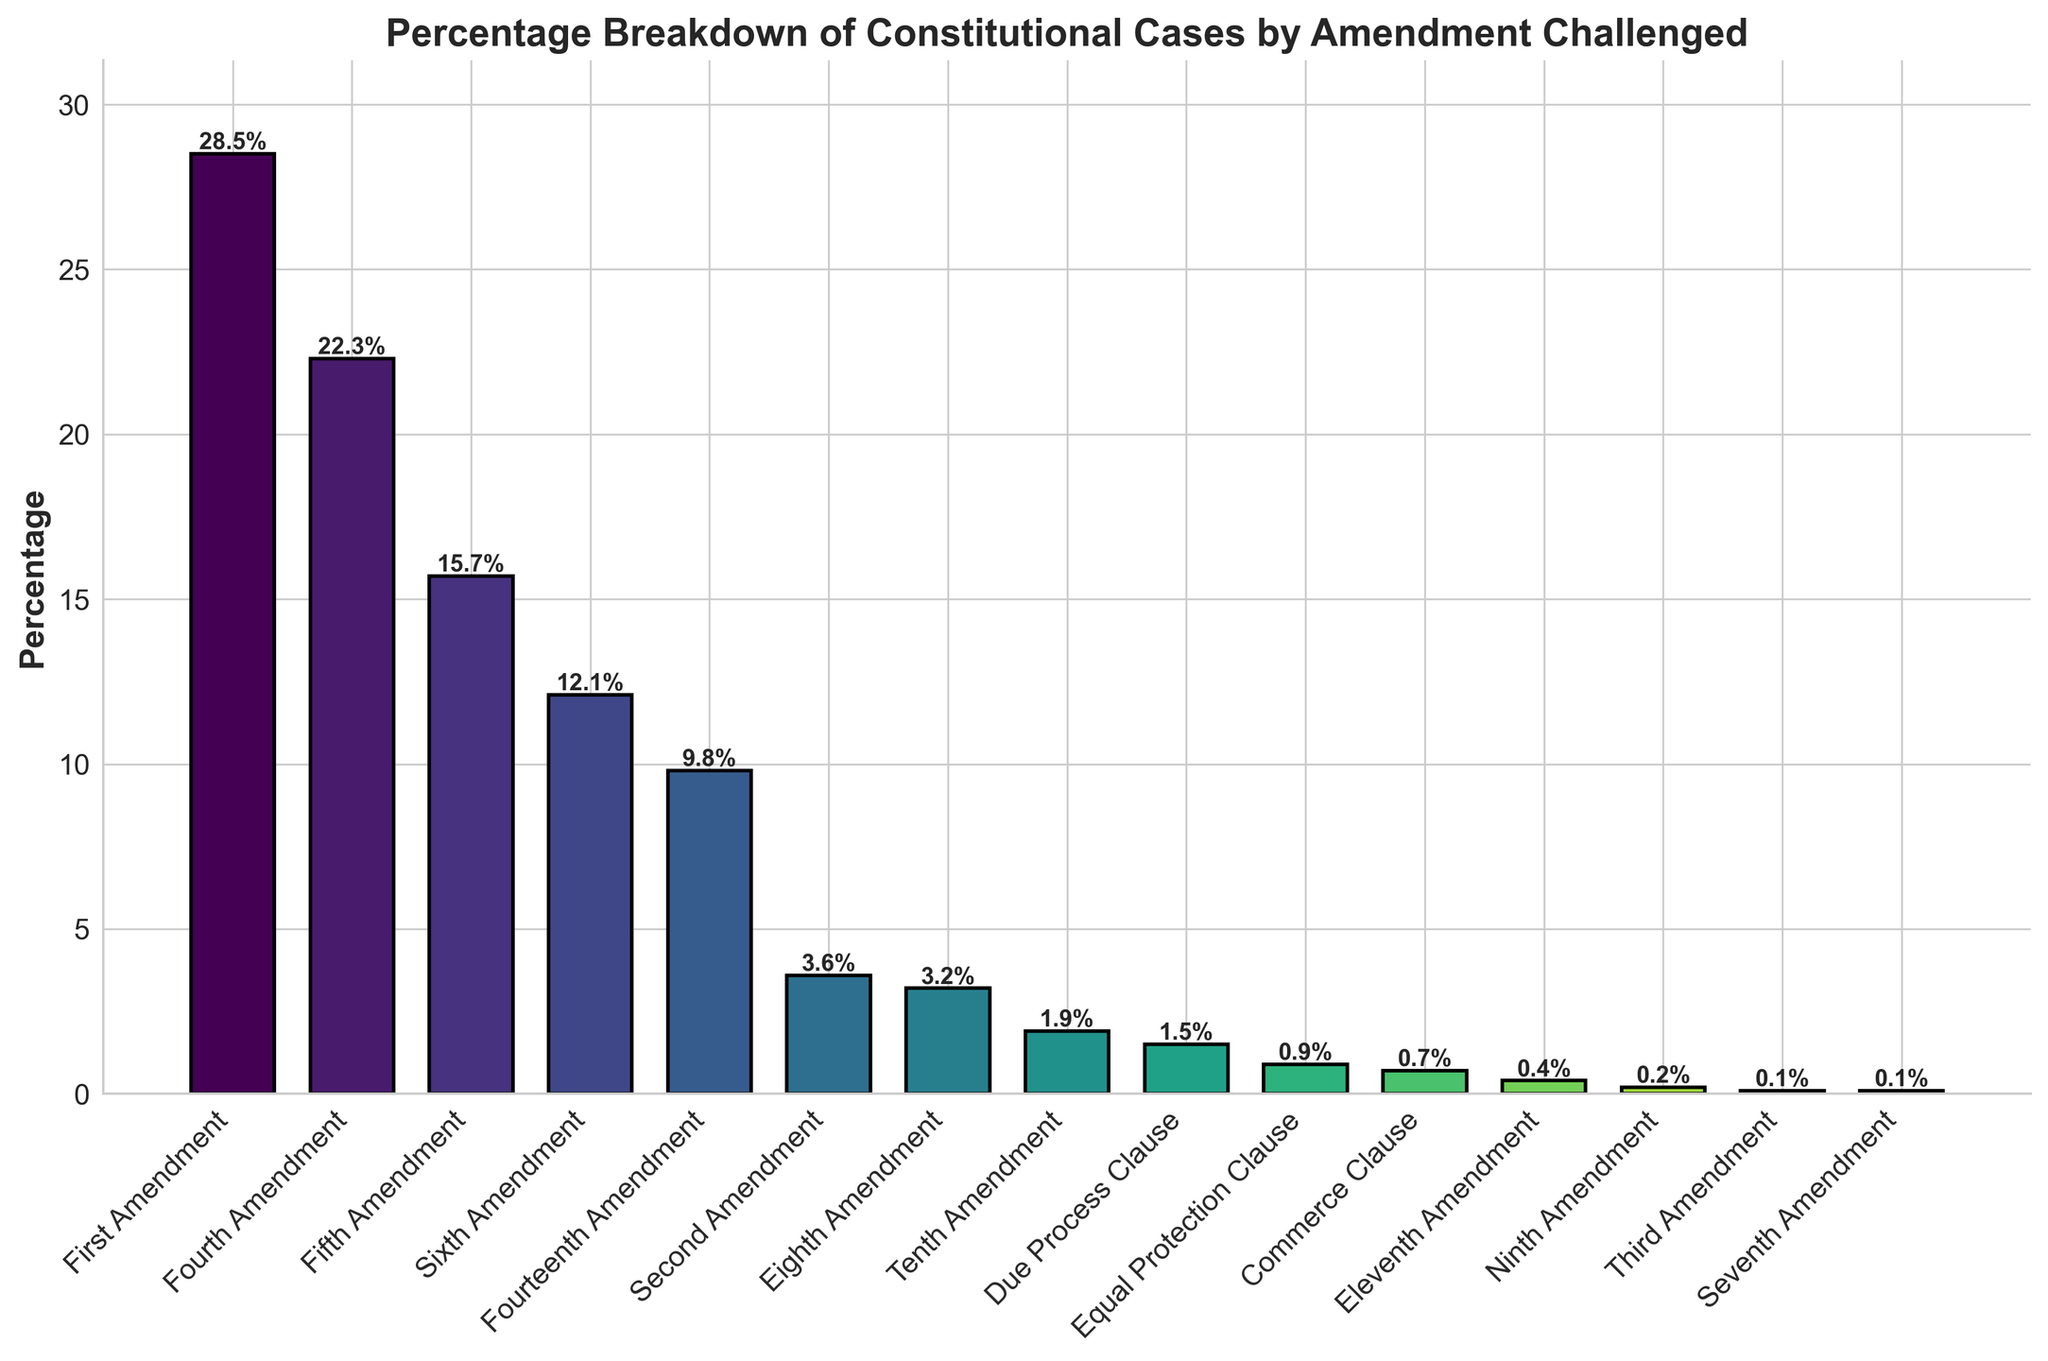Which amendment is challenged the most in constitutional cases? The figure shows the percentage breakdown of constitutional cases by amendment challenged. The highest bar represents the most challenged amendment.
Answer: First Amendment Which amendment is challenged the least in constitutional cases? The figure shows the percentage breakdown of constitutional cases by amendment challenged. The smallest bar represents the least challenged amendment.
Answer: Seventh Amendment (tie with Third Amendment and Ninth Amendment) What is the combined percentage of cases challenging the Fourth and Fifth Amendments? To find the combined percentage of cases challenging the Fourth and Fifth Amendments, add their individual percentages: 22.3% + 15.7% = 38.0%
Answer: 38.0% How much more frequently is the First Amendment challenged compared to the Eighth Amendment? Subtract the percentage of cases challenging the Eighth Amendment from the percentage of cases challenging the First Amendment: 28.5% - 3.2% = 25.3%
Answer: 25.3% What is the percentage difference between challenges based on the Second Amendment and the Tenth Amendment? Subtract the percentage of cases challenging the Tenth Amendment from the percentage of cases challenging the Second Amendment: 3.6% - 1.9% = 1.7%
Answer: 1.7% Which amendment among the Fourth, Fourteenth, and Sixth is challenged the most? Compare the percentages of cases challenging the Fourth (22.3%), Fourteenth (9.8%), and Sixth (12.1%) Amendments. The Fourth Amendment has the highest percentage.
Answer: Fourth Amendment Which clause is challenged more, the Due Process Clause or the Equal Protection Clause? Compare the percentages of cases challenging the Due Process Clause (1.5%) and the Equal Protection Clause (0.9%). The Due Process Clause has a higher percentage.
Answer: Due Process Clause What is the total percentage of constitutional cases involving the First, Fourth, and Fifth Amendments? Add the percentages of cases involving the First (28.5%), Fourth (22.3%), and Fifth (15.7%) Amendments: 28.5% + 22.3% + 15.7% = 66.5%
Answer: 66.5% By how much does the percentage of cases involving the Sixth Amendment exceed those involving the Eighth Amendment? Subtract the percentage of cases challenging the Eighth Amendment from those challenging the Sixth Amendment: 12.1% - 3.2% = 8.9%
Answer: 8.9% Which amendment shows the smallest percentage increase when compared to the Ninth Amendment? Subtract the percentage of the Ninth Amendment (0.2%) from each amendment's percentage and find the smallest positive difference. The Tenth Amendment (1.9%) - Ninth Amendment (0.2%) = 1.7% is the smallest increase.
Answer: Tenth Amendment 